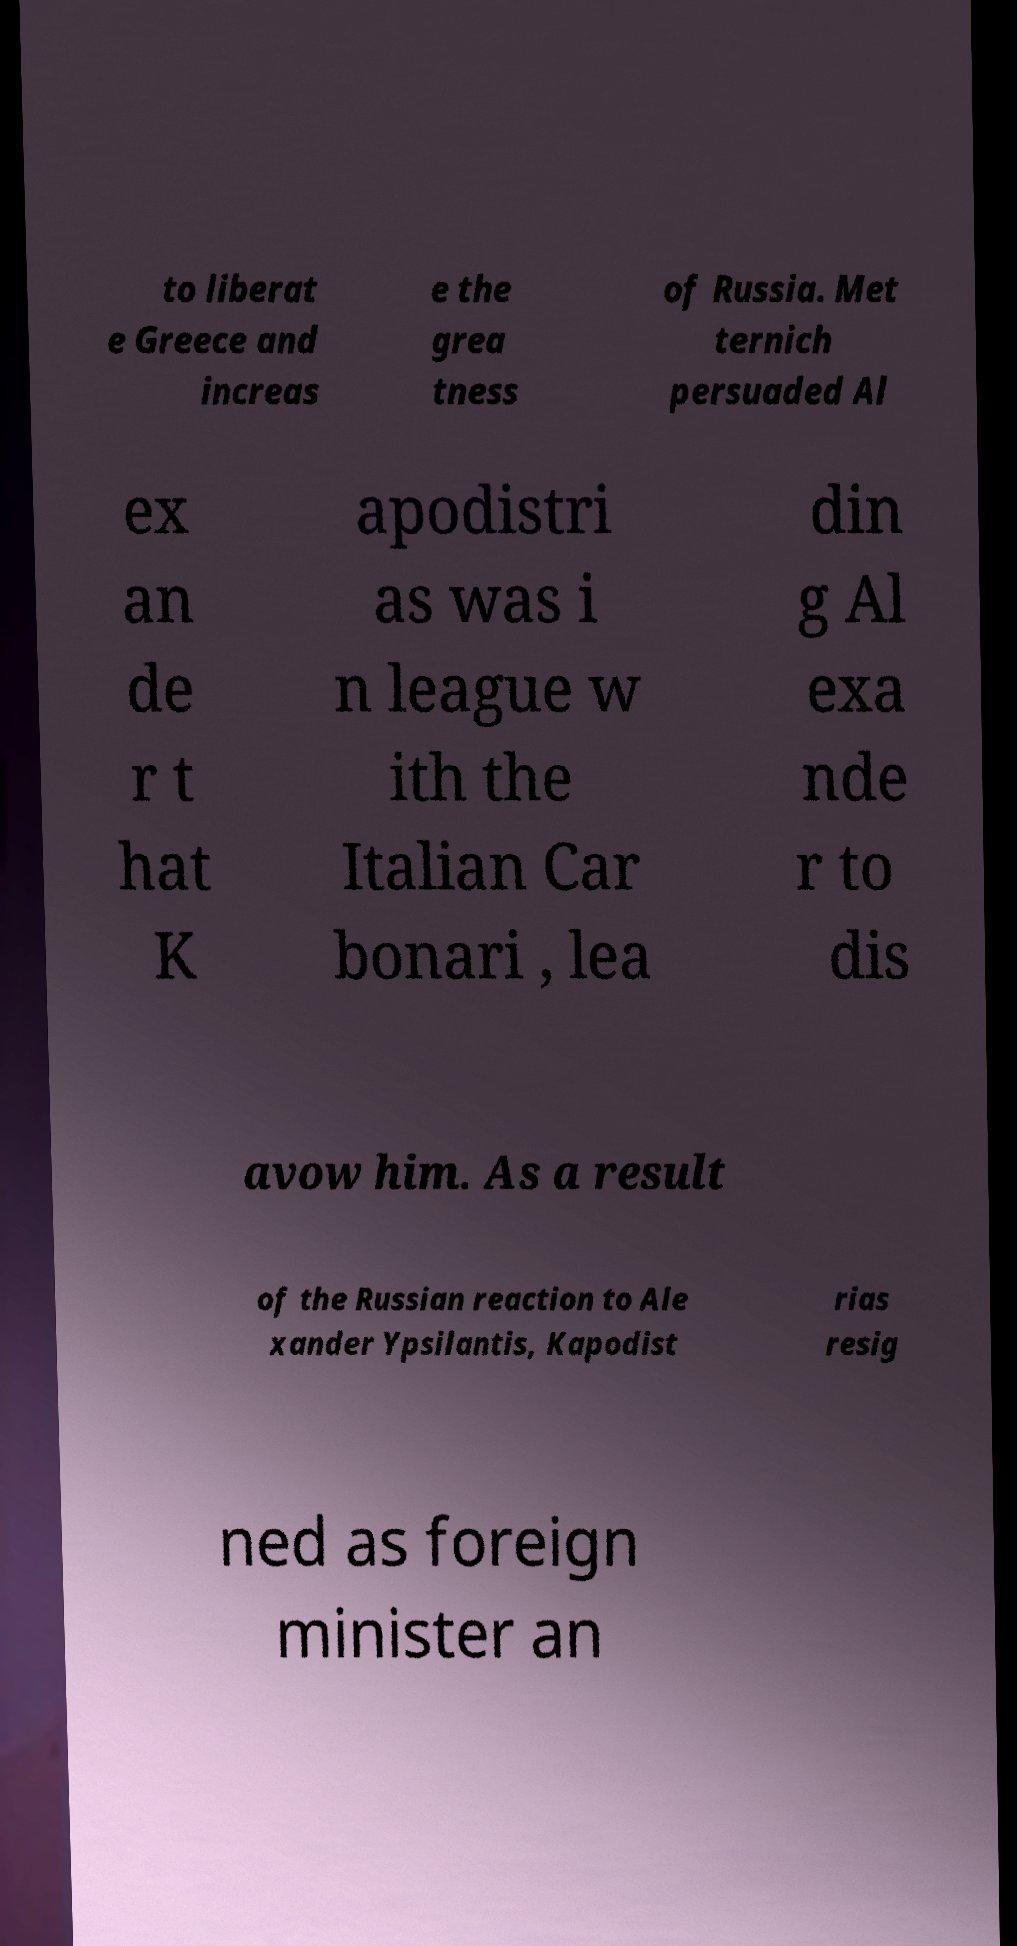Can you accurately transcribe the text from the provided image for me? to liberat e Greece and increas e the grea tness of Russia. Met ternich persuaded Al ex an de r t hat K apodistri as was i n league w ith the Italian Car bonari , lea din g Al exa nde r to dis avow him. As a result of the Russian reaction to Ale xander Ypsilantis, Kapodist rias resig ned as foreign minister an 